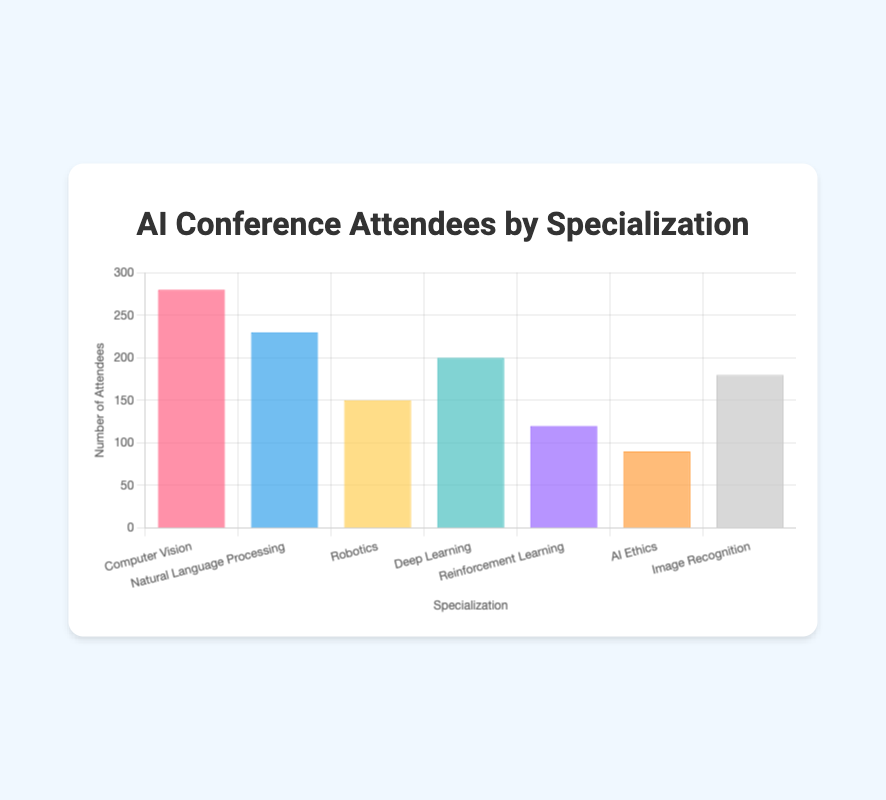What is the title of the chart? The title is displayed at the top of the figure and usually summarizes what the chart represents. Here, it is written in the center above the chart.
Answer: AI Conference Attendees by Specialization Which specialization has the highest number of attendees? Look for the tallest bar in the chart, which represents the specialization with the highest number of attendees.
Answer: Computer Vision What mood is associated with the Natural Language Processing attendees? The mood is indicated by an emoji linked to each specialization. For Natural Language Processing, find the corresponding emoji.
Answer: 🙂 Which specializations have more than 200 attendees? Identify the bars that extend above the 200 mark on the y-axis.
Answer: Computer Vision and Natural Language Processing How does the number of attendees in Deep Learning compare to that in Image Recognition? Compare the heights of the bars for Deep Learning and Image Recognition.
Answer: Deep Learning has more attendees than Image Recognition Which specialization has the fewest attendees, and what is the corresponding mood? Find the shortest bar in the chart and the emoji linked to it.
Answer: AI Ethics, 😐 